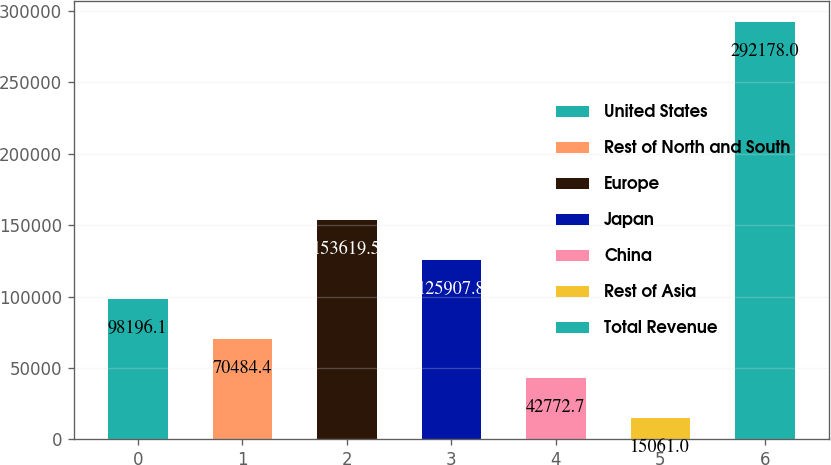<chart> <loc_0><loc_0><loc_500><loc_500><bar_chart><fcel>United States<fcel>Rest of North and South<fcel>Europe<fcel>Japan<fcel>China<fcel>Rest of Asia<fcel>Total Revenue<nl><fcel>98196.1<fcel>70484.4<fcel>153620<fcel>125908<fcel>42772.7<fcel>15061<fcel>292178<nl></chart> 